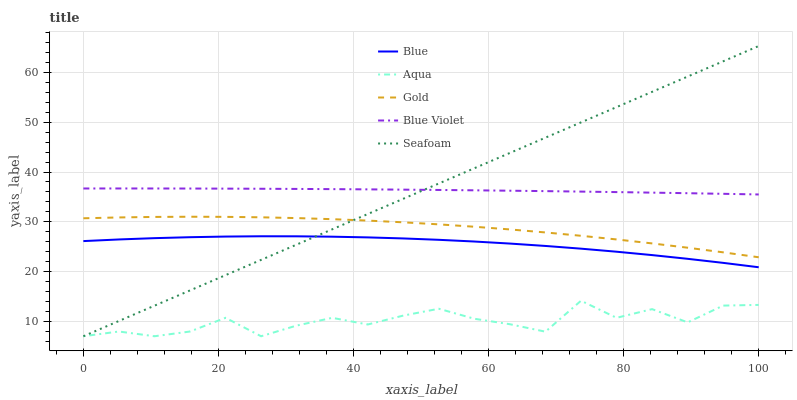Does Aqua have the minimum area under the curve?
Answer yes or no. Yes. Does Blue Violet have the maximum area under the curve?
Answer yes or no. Yes. Does Blue Violet have the minimum area under the curve?
Answer yes or no. No. Does Aqua have the maximum area under the curve?
Answer yes or no. No. Is Seafoam the smoothest?
Answer yes or no. Yes. Is Aqua the roughest?
Answer yes or no. Yes. Is Blue Violet the smoothest?
Answer yes or no. No. Is Blue Violet the roughest?
Answer yes or no. No. Does Blue Violet have the lowest value?
Answer yes or no. No. Does Seafoam have the highest value?
Answer yes or no. Yes. Does Blue Violet have the highest value?
Answer yes or no. No. Is Blue less than Gold?
Answer yes or no. Yes. Is Gold greater than Aqua?
Answer yes or no. Yes. Does Gold intersect Seafoam?
Answer yes or no. Yes. Is Gold less than Seafoam?
Answer yes or no. No. Is Gold greater than Seafoam?
Answer yes or no. No. Does Blue intersect Gold?
Answer yes or no. No. 